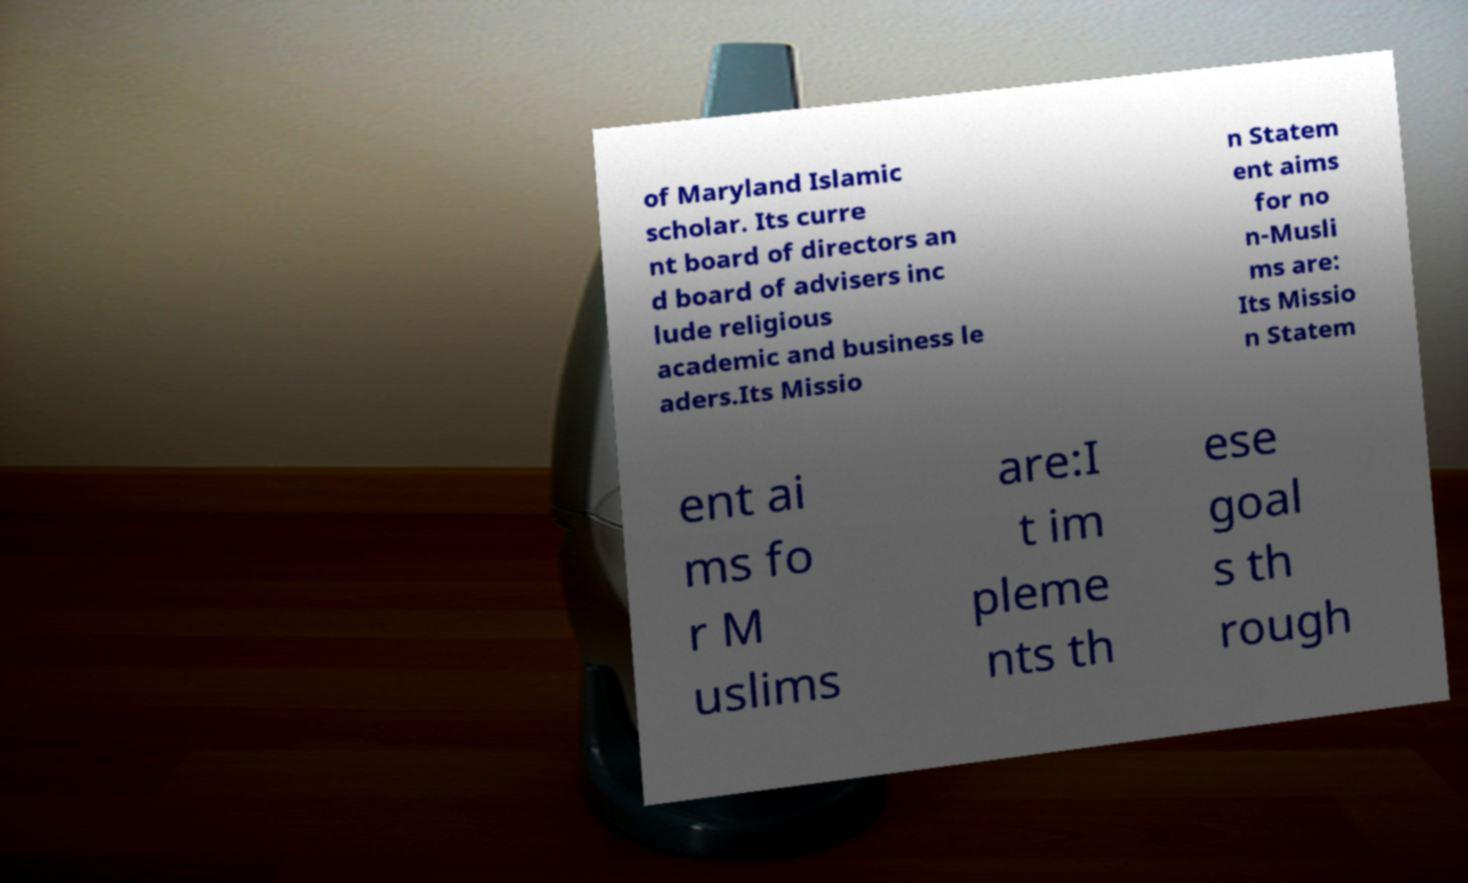I need the written content from this picture converted into text. Can you do that? of Maryland Islamic scholar. Its curre nt board of directors an d board of advisers inc lude religious academic and business le aders.Its Missio n Statem ent aims for no n-Musli ms are: Its Missio n Statem ent ai ms fo r M uslims are:I t im pleme nts th ese goal s th rough 